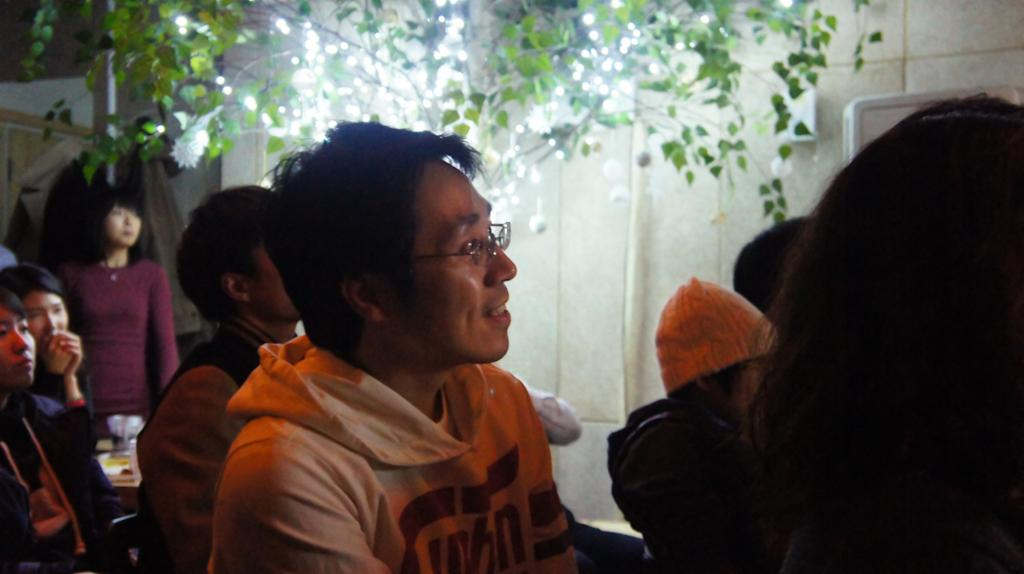What can be seen in the image? There are people, objects, a wall, a tree, lights, and a pole in the image. Can you describe the people in the image? The facts provided do not give specific details about the people in the image. What type of objects are present in the image? The facts provided do not give specific details about the objects in the image. What is the wall in the image made of? The facts provided do not give specific details about the wall in the image. What type of lights are in the image? The facts provided do not give specific details about the lights in the image. What is the pole in the image used for? The facts provided do not give specific details about the pole in the image. What type of punishment is being administered to the tree in the image? There is no punishment being administered to the tree in the image; it is a stationary object. What type of bulb is used to illuminate the pole in the image? The facts provided do not give specific details about the bulb used to illuminate the pole in the image. 